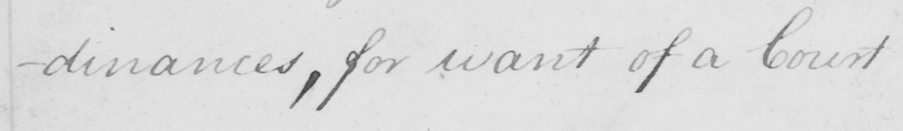What text is written in this handwritten line? -dinances , for want of a Court 